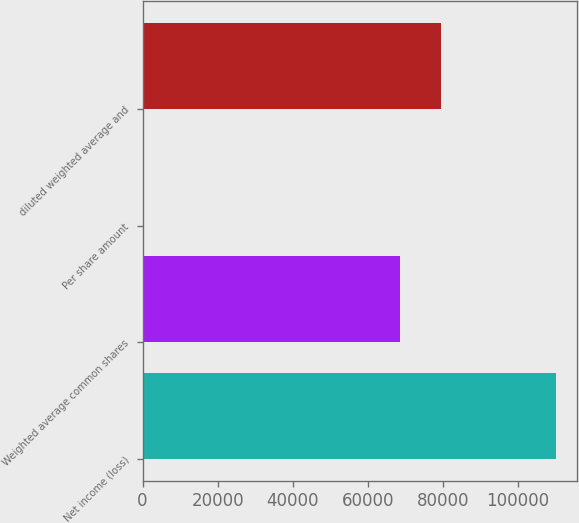<chart> <loc_0><loc_0><loc_500><loc_500><bar_chart><fcel>Net income (loss)<fcel>Weighted average common shares<fcel>Per share amount<fcel>diluted weighted average and<nl><fcel>110113<fcel>68463<fcel>1.61<fcel>79474.1<nl></chart> 